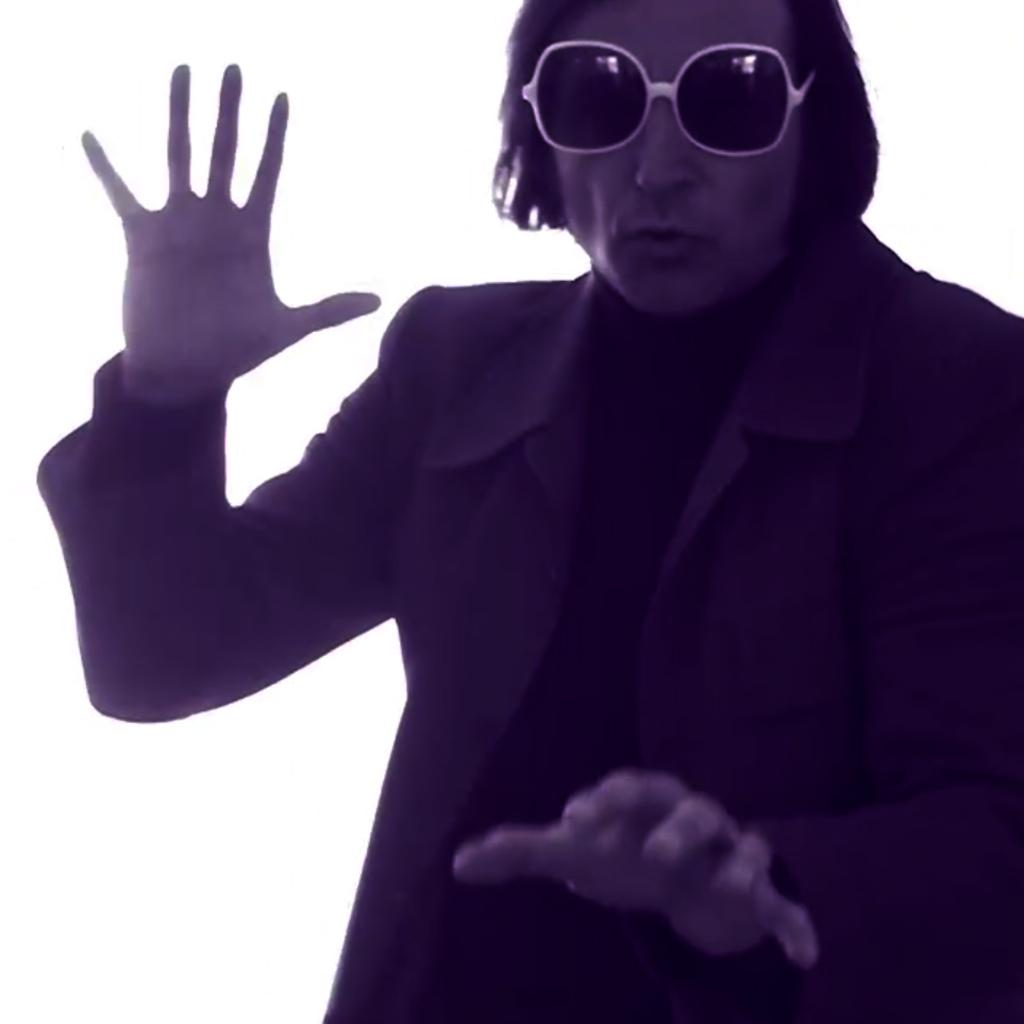Who is present in the image? There is a man in the image. What is the man wearing in the image? The man is wearing glasses in the image. What is the color of the background in the image? The background of the image is white. What type of band can be seen playing in the image? There is no band present in the image; it only features a man wearing glasses against a white background. 